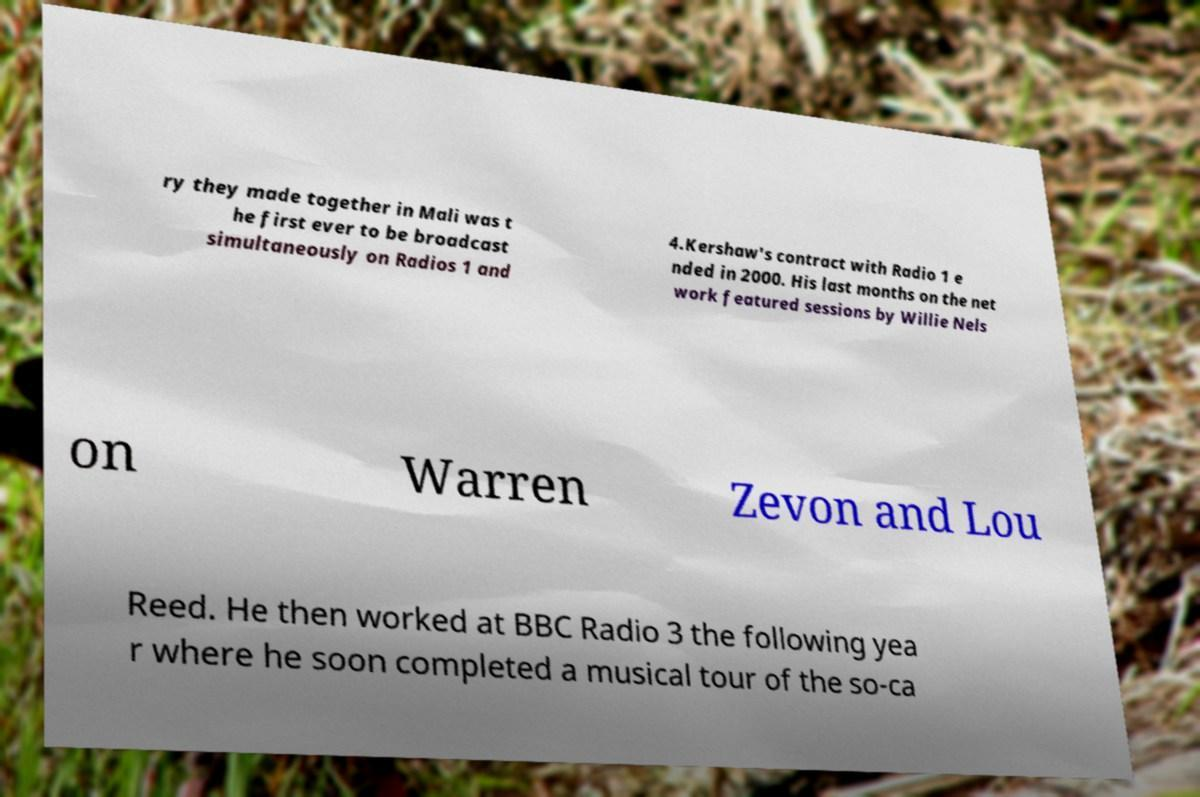Can you accurately transcribe the text from the provided image for me? ry they made together in Mali was t he first ever to be broadcast simultaneously on Radios 1 and 4.Kershaw's contract with Radio 1 e nded in 2000. His last months on the net work featured sessions by Willie Nels on Warren Zevon and Lou Reed. He then worked at BBC Radio 3 the following yea r where he soon completed a musical tour of the so-ca 